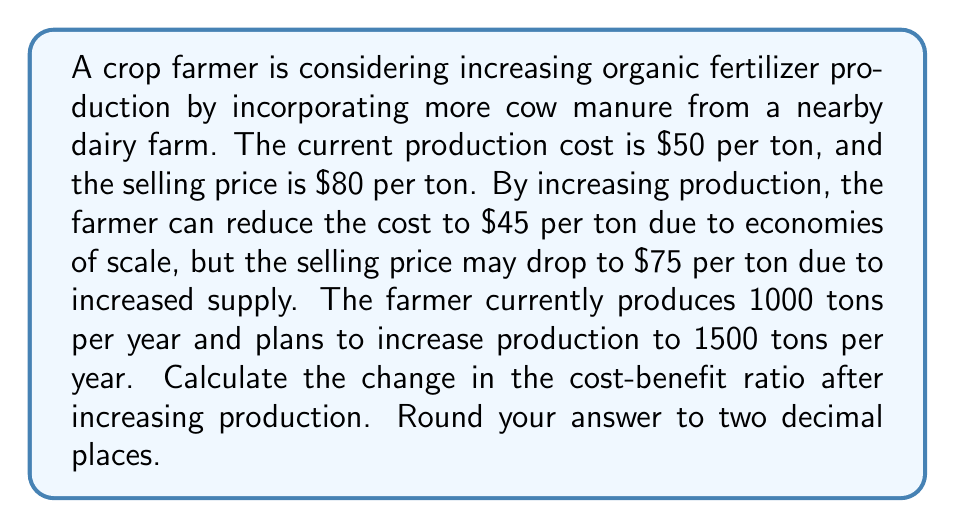What is the answer to this math problem? To solve this problem, we need to calculate the cost-benefit ratio before and after the production increase, then compare the two.

1. Calculate the current cost-benefit ratio:
   - Current cost per ton = $50
   - Current selling price per ton = $80
   - Current cost-benefit ratio = $\frac{\text{Benefit}}{\text{Cost}} = \frac{80}{50} = 1.60$

2. Calculate the new cost-benefit ratio:
   - New cost per ton = $45
   - New selling price per ton = $75
   - New cost-benefit ratio = $\frac{\text{Benefit}}{\text{Cost}} = \frac{75}{45} = 1.67$

3. Calculate the change in cost-benefit ratio:
   $\text{Change} = \text{New ratio} - \text{Current ratio} = 1.67 - 1.60 = 0.07$

Therefore, the cost-benefit ratio will increase by 0.07 after increasing production.
Answer: 0.07 